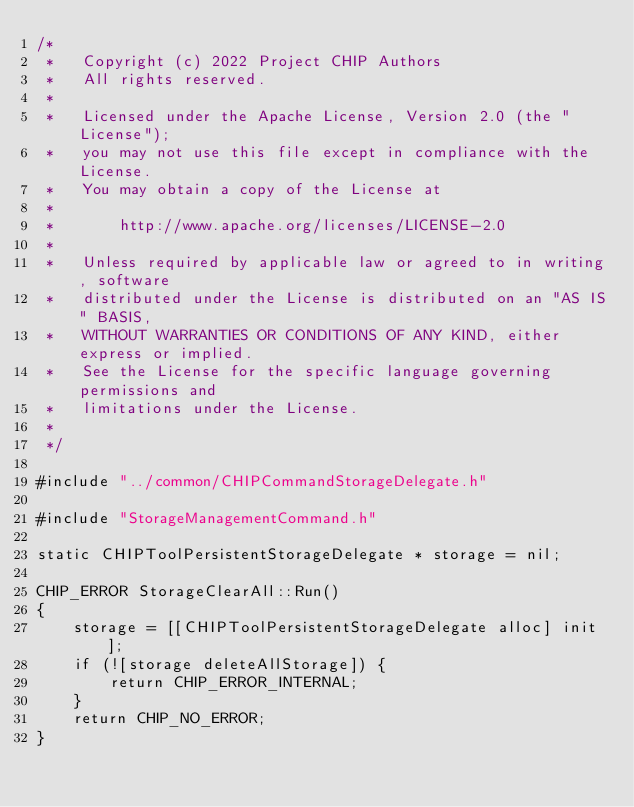Convert code to text. <code><loc_0><loc_0><loc_500><loc_500><_ObjectiveC_>/*
 *   Copyright (c) 2022 Project CHIP Authors
 *   All rights reserved.
 *
 *   Licensed under the Apache License, Version 2.0 (the "License");
 *   you may not use this file except in compliance with the License.
 *   You may obtain a copy of the License at
 *
 *       http://www.apache.org/licenses/LICENSE-2.0
 *
 *   Unless required by applicable law or agreed to in writing, software
 *   distributed under the License is distributed on an "AS IS" BASIS,
 *   WITHOUT WARRANTIES OR CONDITIONS OF ANY KIND, either express or implied.
 *   See the License for the specific language governing permissions and
 *   limitations under the License.
 *
 */

#include "../common/CHIPCommandStorageDelegate.h"

#include "StorageManagementCommand.h"

static CHIPToolPersistentStorageDelegate * storage = nil;

CHIP_ERROR StorageClearAll::Run()
{
    storage = [[CHIPToolPersistentStorageDelegate alloc] init];
    if (![storage deleteAllStorage]) {
        return CHIP_ERROR_INTERNAL;
    }
    return CHIP_NO_ERROR;
}
</code> 